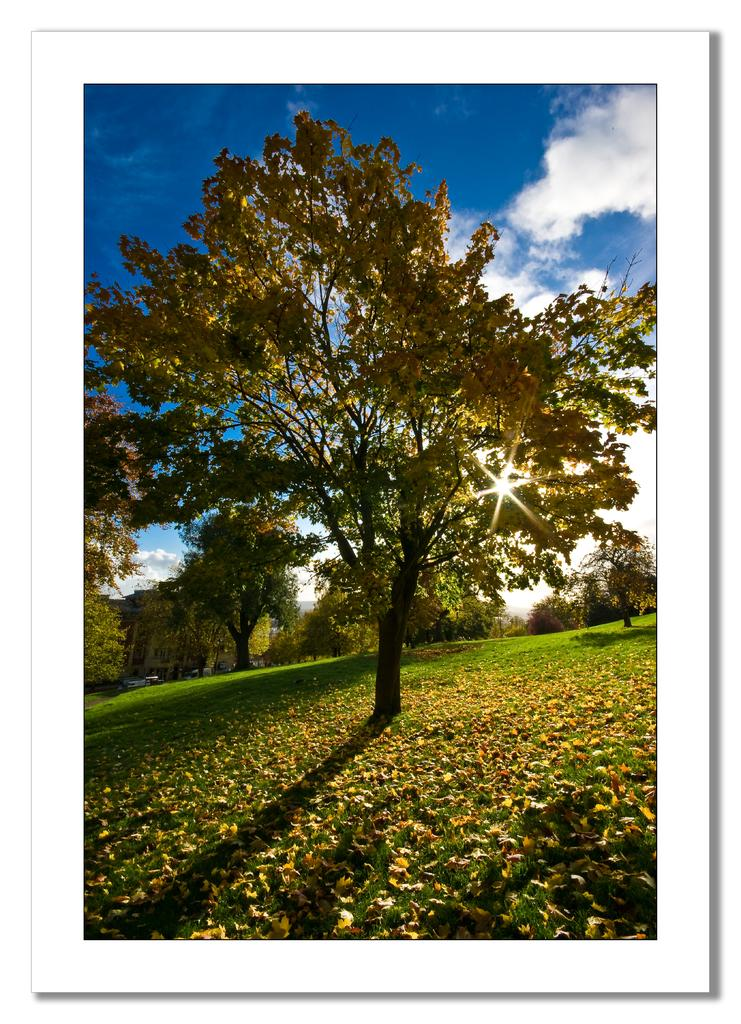What type of vegetation is visible in the image? There are many trees in the image. What type of ground cover is present in the image? There is grass visible in the image. What is the condition of the sky in the background of the image? The sky is cloudy in the background of the image. Can you tell me how many minutes it takes for the skate to complete a lap in the image? There is no skate present in the image, so it is not possible to determine how many minutes it takes for the skate to complete a lap. What color is the nose of the person in the image? There are no people or noses visible in the image. 